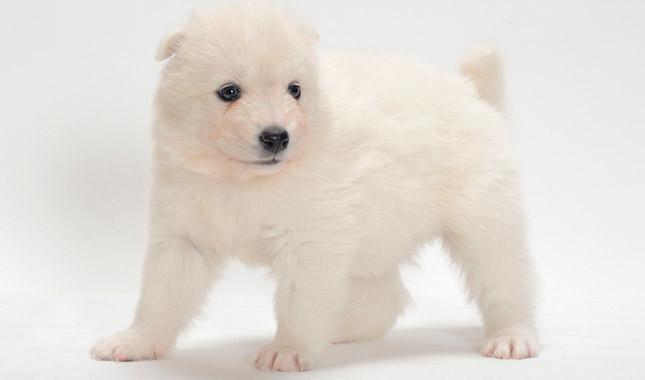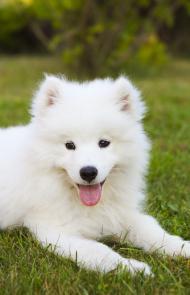The first image is the image on the left, the second image is the image on the right. Evaluate the accuracy of this statement regarding the images: "There are two white dogs standing outside.". Is it true? Answer yes or no. No. 